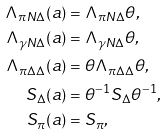Convert formula to latex. <formula><loc_0><loc_0><loc_500><loc_500>\Lambda _ { \pi N \Delta } ( a ) & = \Lambda _ { \pi N \Delta } \theta , \\ \Lambda _ { \gamma N \Delta } ( a ) & = \Lambda _ { \gamma N \Delta } \theta , \\ \Lambda _ { \pi \Delta \Delta } ( a ) & = \theta \Lambda _ { \pi \Delta \Delta } \theta , \\ S _ { \Delta } ( a ) & = \theta ^ { - 1 } S _ { \Delta } \theta ^ { - 1 } , \\ S _ { \pi } ( a ) & = S _ { \pi } ,</formula> 